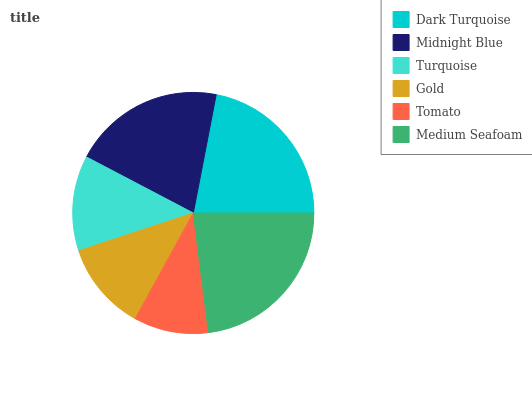Is Tomato the minimum?
Answer yes or no. Yes. Is Medium Seafoam the maximum?
Answer yes or no. Yes. Is Midnight Blue the minimum?
Answer yes or no. No. Is Midnight Blue the maximum?
Answer yes or no. No. Is Dark Turquoise greater than Midnight Blue?
Answer yes or no. Yes. Is Midnight Blue less than Dark Turquoise?
Answer yes or no. Yes. Is Midnight Blue greater than Dark Turquoise?
Answer yes or no. No. Is Dark Turquoise less than Midnight Blue?
Answer yes or no. No. Is Midnight Blue the high median?
Answer yes or no. Yes. Is Turquoise the low median?
Answer yes or no. Yes. Is Tomato the high median?
Answer yes or no. No. Is Tomato the low median?
Answer yes or no. No. 